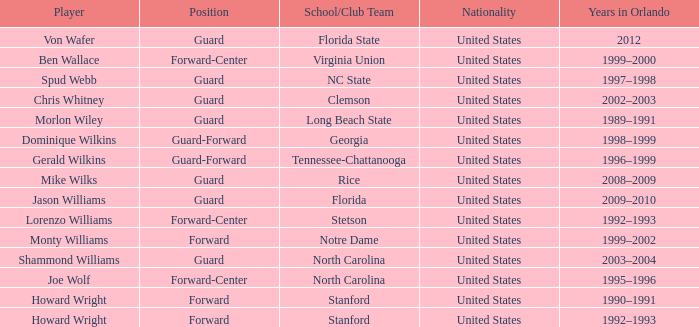What School/Club did Dominique Wilkins play for? Georgia. 